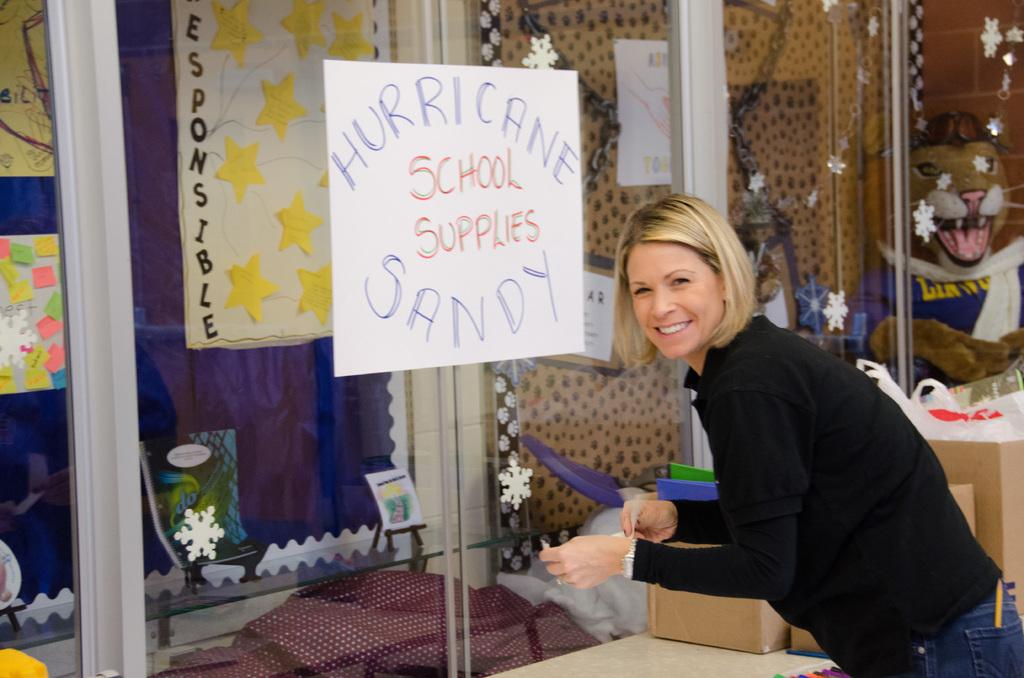What is the lady doing in the image? The lady is standing and smiling in the image. What can be seen on the glass door in the image? There are posters placed on the glass door in the image. What decorative elements are visible in the image? There are many stickers visible in the image. What objects are located at the bottom of the image? There are boxes at the bottom of the image. What type of shirt or sweater is the lady wearing in the image? The provided facts do not mention any shirt or sweater worn by the lady in the image. 